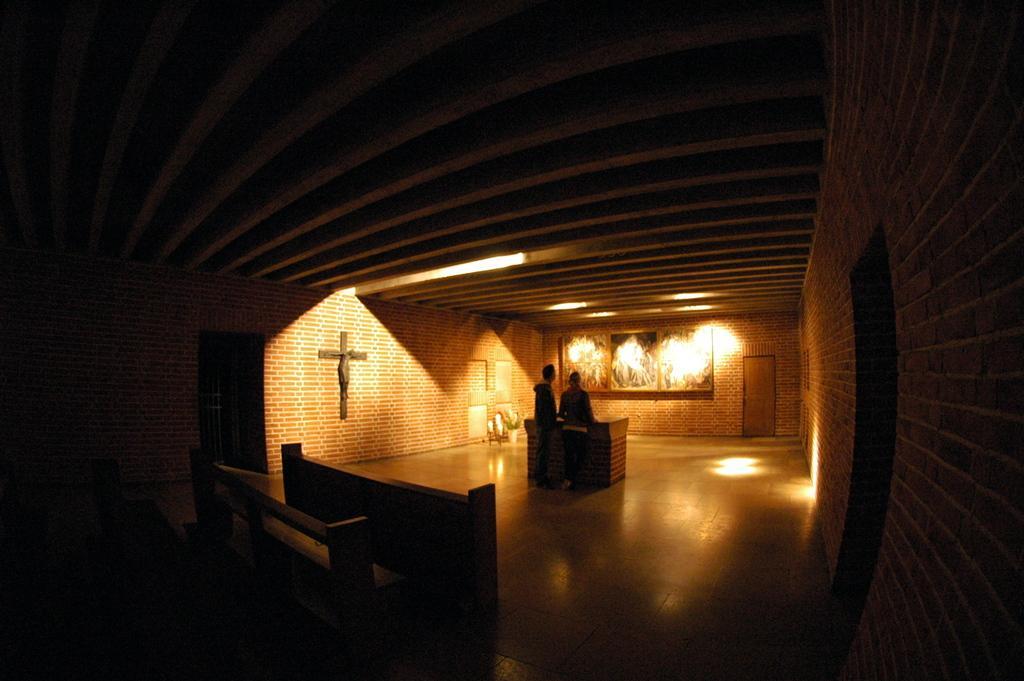Describe this image in one or two sentences. I think, this picture is taken in a church. The room is dark. In the center, there is a table. Beside the table there is a man and a woman. To the wall, there is a statue. To the other wall, there are frames and door. At the bottom, there are benches. 